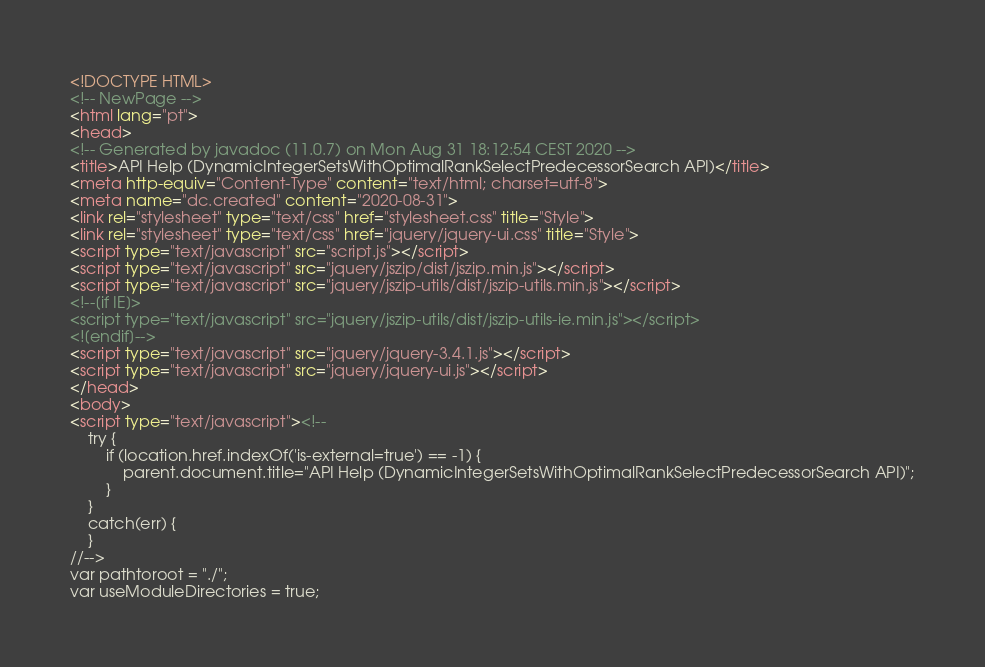Convert code to text. <code><loc_0><loc_0><loc_500><loc_500><_HTML_><!DOCTYPE HTML>
<!-- NewPage -->
<html lang="pt">
<head>
<!-- Generated by javadoc (11.0.7) on Mon Aug 31 18:12:54 CEST 2020 -->
<title>API Help (DynamicIntegerSetsWithOptimalRankSelectPredecessorSearch API)</title>
<meta http-equiv="Content-Type" content="text/html; charset=utf-8">
<meta name="dc.created" content="2020-08-31">
<link rel="stylesheet" type="text/css" href="stylesheet.css" title="Style">
<link rel="stylesheet" type="text/css" href="jquery/jquery-ui.css" title="Style">
<script type="text/javascript" src="script.js"></script>
<script type="text/javascript" src="jquery/jszip/dist/jszip.min.js"></script>
<script type="text/javascript" src="jquery/jszip-utils/dist/jszip-utils.min.js"></script>
<!--[if IE]>
<script type="text/javascript" src="jquery/jszip-utils/dist/jszip-utils-ie.min.js"></script>
<![endif]-->
<script type="text/javascript" src="jquery/jquery-3.4.1.js"></script>
<script type="text/javascript" src="jquery/jquery-ui.js"></script>
</head>
<body>
<script type="text/javascript"><!--
    try {
        if (location.href.indexOf('is-external=true') == -1) {
            parent.document.title="API Help (DynamicIntegerSetsWithOptimalRankSelectPredecessorSearch API)";
        }
    }
    catch(err) {
    }
//-->
var pathtoroot = "./";
var useModuleDirectories = true;</code> 